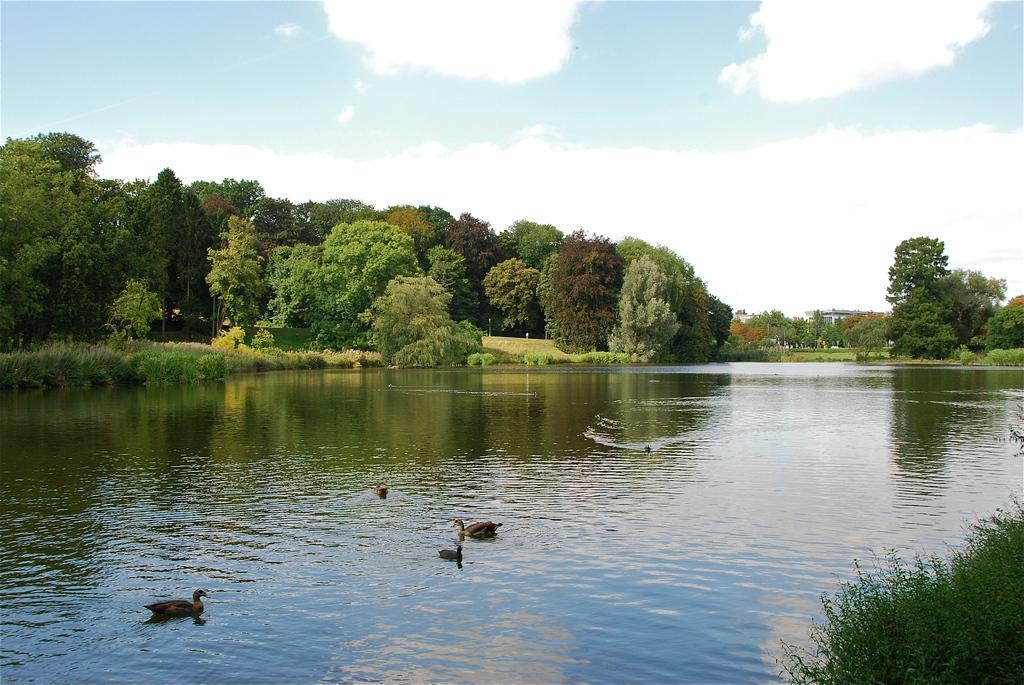Please provide a concise description of this image. This image is clicked outside. There is water in the middle. There are trees in the middle. There is sky at the top. There are ducks in the water. 